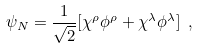<formula> <loc_0><loc_0><loc_500><loc_500>\psi _ { N } = \frac { 1 } { \sqrt { 2 } } [ \chi ^ { \rho } \phi ^ { \rho } + \chi ^ { \lambda } \phi ^ { \lambda } ] \ ,</formula> 